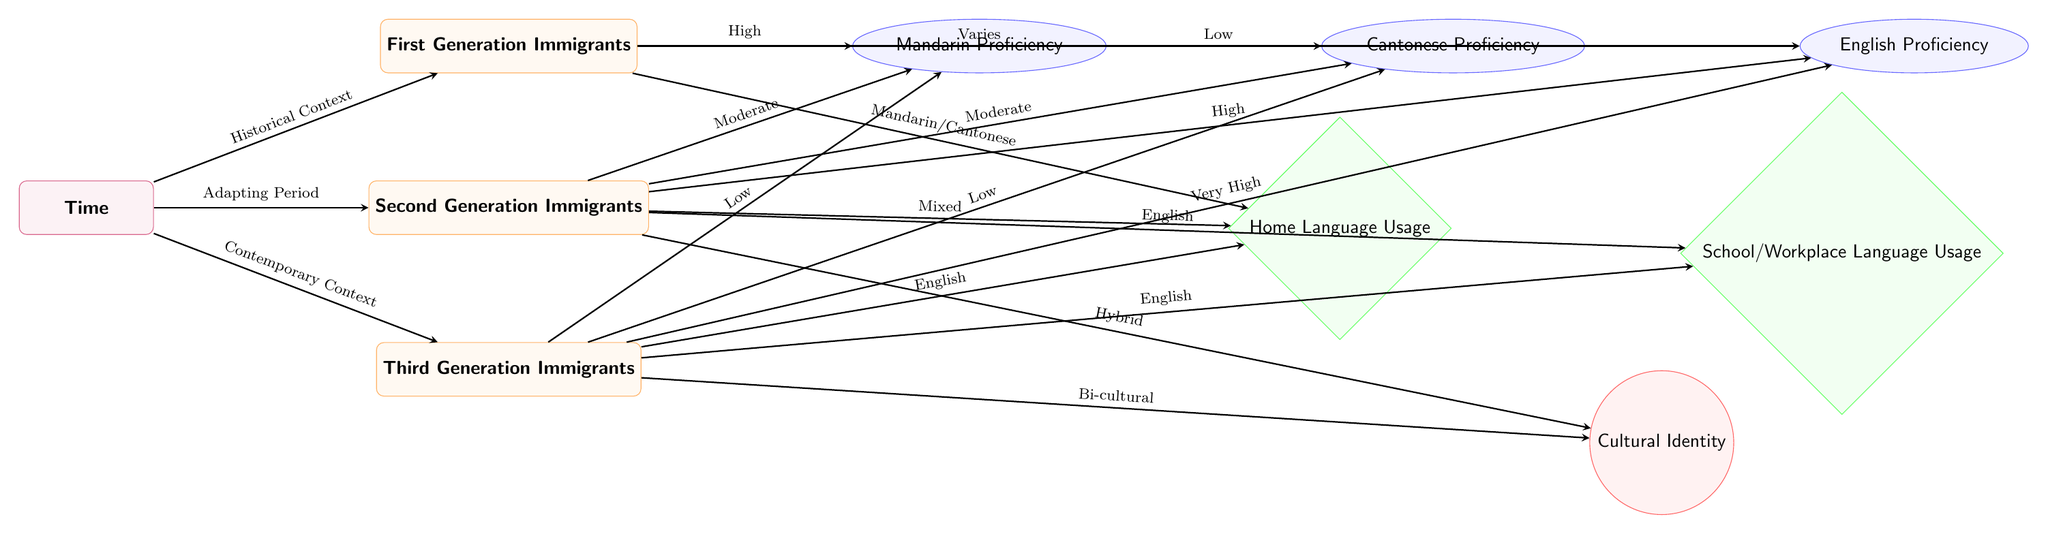What is the proficiency level of First Generation Immigrants in Mandarin? The diagram shows an arrow pointing from the First Generation Immigrants to the Mandarin Proficiency node with a label indicating "High." Therefore, the proficiency level is high.
Answer: High What is the cultural identity of Third Generation Immigrants? The arrow from Third Generation Immigrants points to the identity node labeled "Bi-cultural." Thus, the cultural identity is bi-cultural.
Answer: Bi-cultural How many generations are represented in the diagram? The diagram has three nodes representing generations: First Generation, Second Generation, and Third Generation. Therefore, there are three generations represented.
Answer: Three What is the home language usage for Second Generation Immigrants? The diagram connects Second Generation Immigrants to the Home Language Usage node with the label "Mixed." Hence, the home language usage is mixed.
Answer: Mixed What is the relationship between the Second Generation Immigrants and English Proficiency? The arrow from Second Generation Immigrants to English Proficiency indicates "High." This means the relationship shows that they have high proficiency in English.
Answer: High What is the context for Third Generation Immigration? The arrow from the time node leads to Third Generation Immigrants with the label "Contemporary Context." This indicates that the context surrounding Third Generation Immigrants is contemporary.
Answer: Contemporary Context What is the language usage trend from First to Third Generation? The use of Mandarin/Cantonese decreases from high in First Generation to low in Third Generation while usage of English increases from low to very high. This shows a trend of diminishing use of native languages and increasing use of English across generations.
Answer: Diminishing native language use, increasing English use What type of relationship does Time have with generations? The node for Time has arrows pointing toward each generation with specific labels: "Historical Context," "Adapting Period," and "Contemporary Context." This indicates that the time node provides contextual backgrounds for each generation.
Answer: Contextual backgrounds for generations 